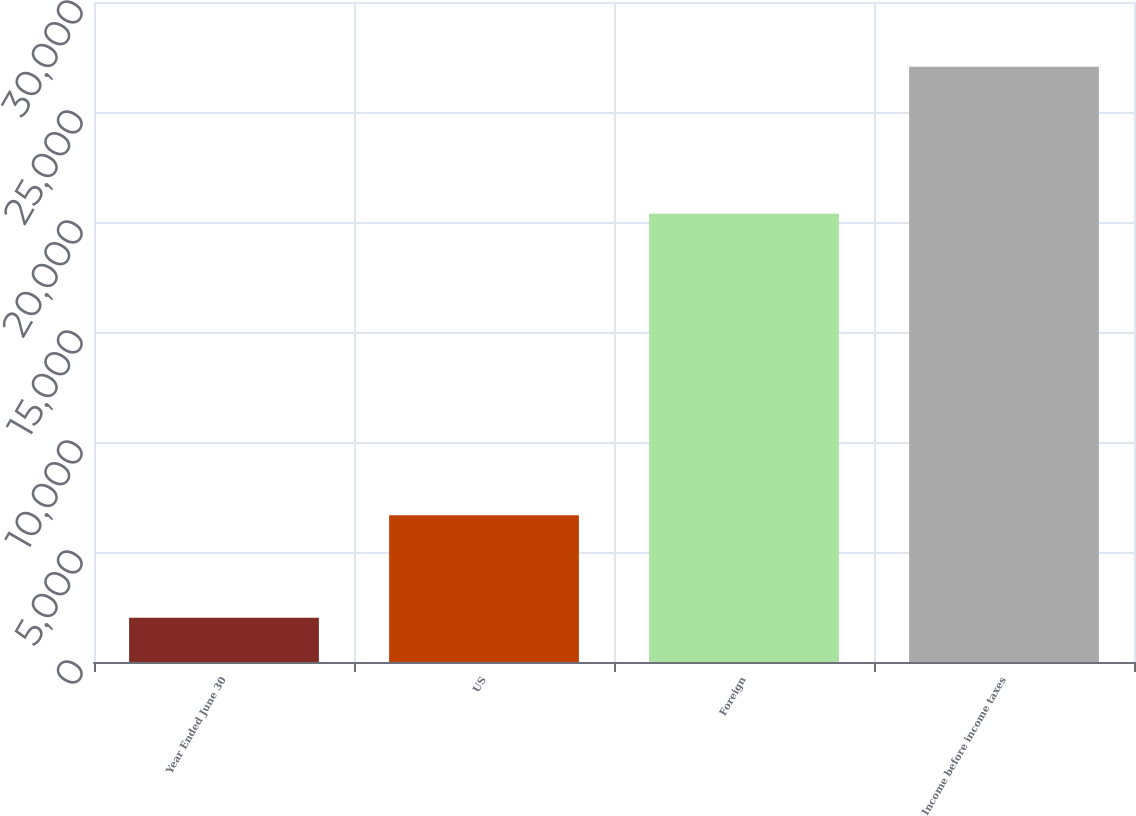Convert chart. <chart><loc_0><loc_0><loc_500><loc_500><bar_chart><fcel>Year Ended June 30<fcel>US<fcel>Foreign<fcel>Income before income taxes<nl><fcel>2013<fcel>6674<fcel>20378<fcel>27052<nl></chart> 